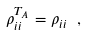Convert formula to latex. <formula><loc_0><loc_0><loc_500><loc_500>\rho ^ { T _ { A } } _ { i i } = \rho _ { i i } \ ,</formula> 